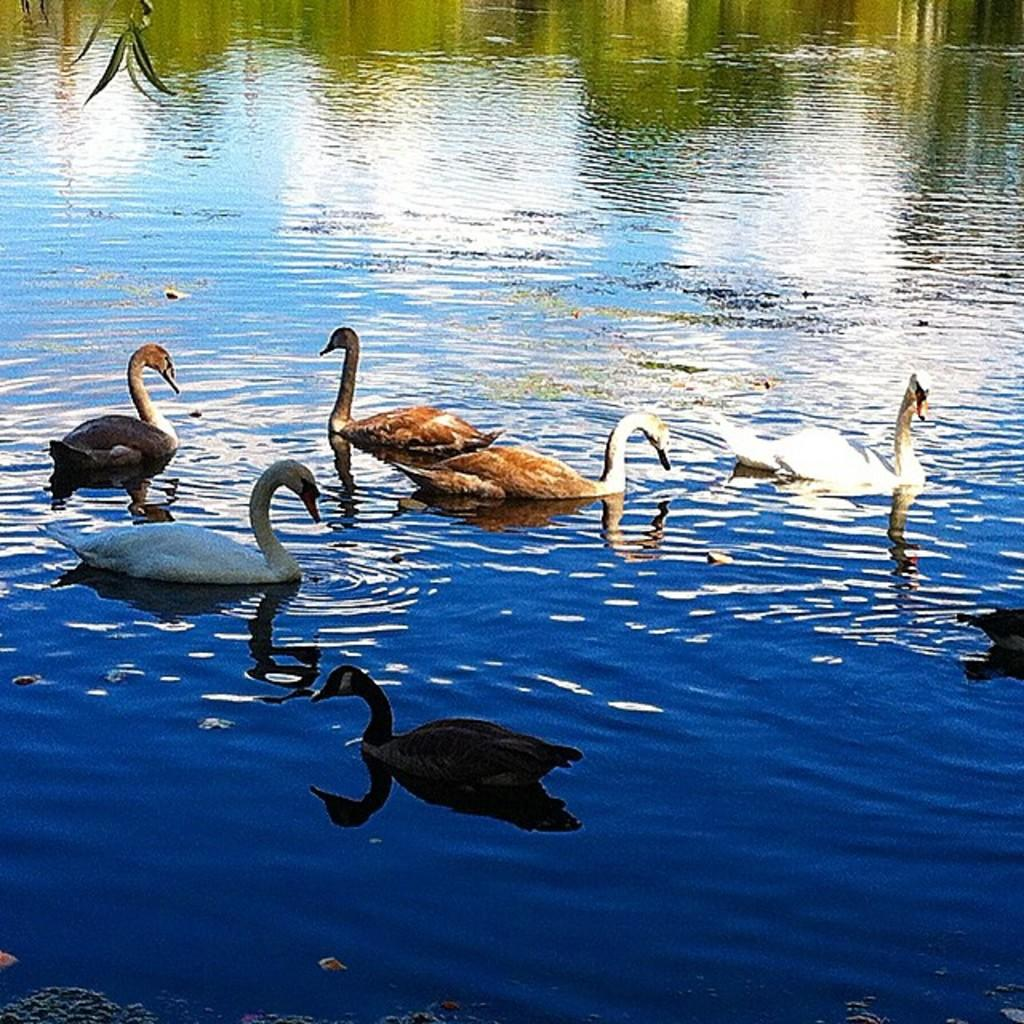What animals are in the foreground of the image? There are ducks in the foreground of the image. Where are the ducks located? The ducks are on the water. What is visible in the background of the image? There is water visible in the background of the image. What type of vegetation can be seen at the top of the image? There are leaves visible at the top of the image. What time does the clock show in the image? There is no clock present in the image, so it is not possible to determine the time. 